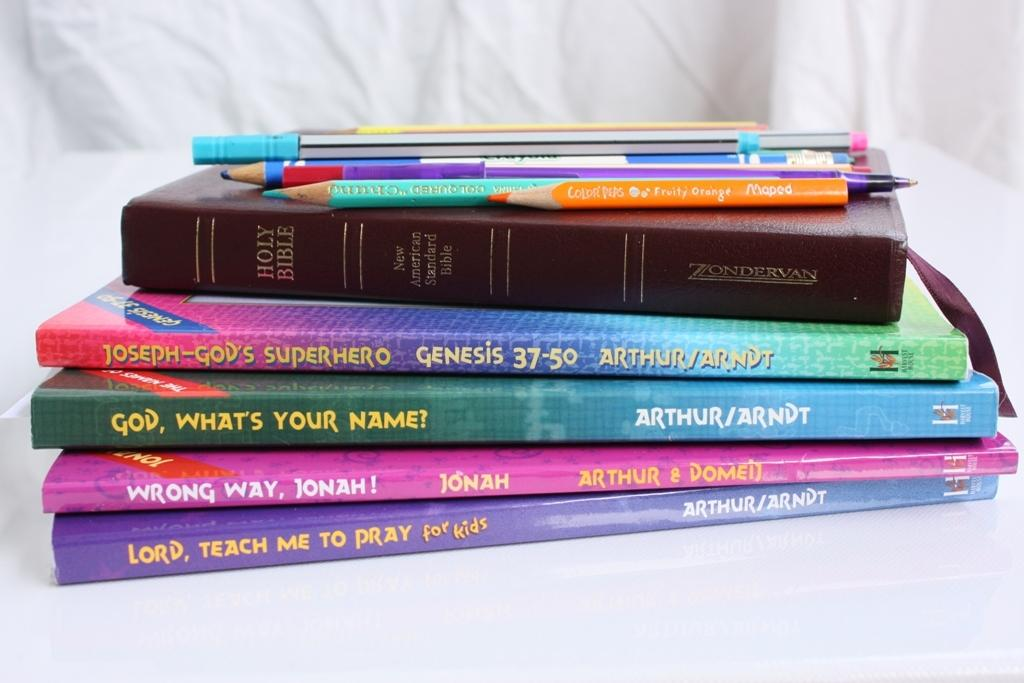<image>
Describe the image concisely. a pile of books that have one that says 'God, what's your name!' on it 